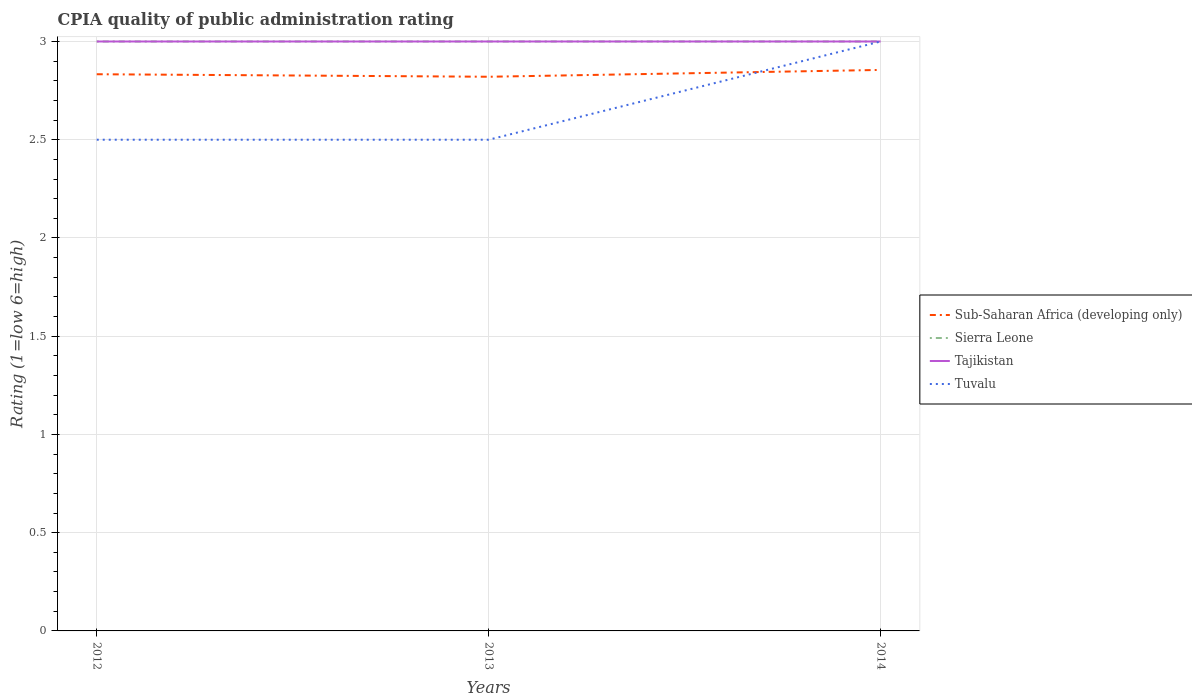Does the line corresponding to Sub-Saharan Africa (developing only) intersect with the line corresponding to Tajikistan?
Your answer should be very brief. No. Is the number of lines equal to the number of legend labels?
Offer a very short reply. Yes. In which year was the CPIA rating in Sierra Leone maximum?
Keep it short and to the point. 2012. What is the total CPIA rating in Sub-Saharan Africa (developing only) in the graph?
Make the answer very short. 0.01. What is the difference between the highest and the second highest CPIA rating in Sub-Saharan Africa (developing only)?
Provide a succinct answer. 0.03. How many lines are there?
Provide a succinct answer. 4. How many years are there in the graph?
Provide a short and direct response. 3. Does the graph contain any zero values?
Offer a very short reply. No. Does the graph contain grids?
Your response must be concise. Yes. Where does the legend appear in the graph?
Your answer should be very brief. Center right. What is the title of the graph?
Keep it short and to the point. CPIA quality of public administration rating. What is the Rating (1=low 6=high) of Sub-Saharan Africa (developing only) in 2012?
Your response must be concise. 2.83. What is the Rating (1=low 6=high) in Tajikistan in 2012?
Provide a short and direct response. 3. What is the Rating (1=low 6=high) of Sub-Saharan Africa (developing only) in 2013?
Offer a terse response. 2.82. What is the Rating (1=low 6=high) of Sierra Leone in 2013?
Your answer should be compact. 3. What is the Rating (1=low 6=high) in Tajikistan in 2013?
Provide a succinct answer. 3. What is the Rating (1=low 6=high) of Tuvalu in 2013?
Offer a terse response. 2.5. What is the Rating (1=low 6=high) in Sub-Saharan Africa (developing only) in 2014?
Provide a succinct answer. 2.86. What is the Rating (1=low 6=high) in Sierra Leone in 2014?
Your answer should be very brief. 3. What is the Rating (1=low 6=high) of Tajikistan in 2014?
Your response must be concise. 3. Across all years, what is the maximum Rating (1=low 6=high) of Sub-Saharan Africa (developing only)?
Give a very brief answer. 2.86. Across all years, what is the maximum Rating (1=low 6=high) of Sierra Leone?
Make the answer very short. 3. Across all years, what is the maximum Rating (1=low 6=high) of Tajikistan?
Provide a succinct answer. 3. Across all years, what is the minimum Rating (1=low 6=high) in Sub-Saharan Africa (developing only)?
Make the answer very short. 2.82. Across all years, what is the minimum Rating (1=low 6=high) of Tuvalu?
Offer a terse response. 2.5. What is the total Rating (1=low 6=high) of Sub-Saharan Africa (developing only) in the graph?
Provide a succinct answer. 8.51. What is the total Rating (1=low 6=high) of Tajikistan in the graph?
Your answer should be compact. 9. What is the difference between the Rating (1=low 6=high) in Sub-Saharan Africa (developing only) in 2012 and that in 2013?
Ensure brevity in your answer.  0.01. What is the difference between the Rating (1=low 6=high) of Tuvalu in 2012 and that in 2013?
Keep it short and to the point. 0. What is the difference between the Rating (1=low 6=high) of Sub-Saharan Africa (developing only) in 2012 and that in 2014?
Offer a terse response. -0.02. What is the difference between the Rating (1=low 6=high) in Sierra Leone in 2012 and that in 2014?
Your answer should be very brief. 0. What is the difference between the Rating (1=low 6=high) of Tajikistan in 2012 and that in 2014?
Your answer should be compact. 0. What is the difference between the Rating (1=low 6=high) in Tuvalu in 2012 and that in 2014?
Give a very brief answer. -0.5. What is the difference between the Rating (1=low 6=high) in Sub-Saharan Africa (developing only) in 2013 and that in 2014?
Keep it short and to the point. -0.03. What is the difference between the Rating (1=low 6=high) of Sierra Leone in 2013 and that in 2014?
Ensure brevity in your answer.  0. What is the difference between the Rating (1=low 6=high) of Sub-Saharan Africa (developing only) in 2012 and the Rating (1=low 6=high) of Sierra Leone in 2013?
Your answer should be very brief. -0.17. What is the difference between the Rating (1=low 6=high) of Sierra Leone in 2012 and the Rating (1=low 6=high) of Tajikistan in 2013?
Provide a short and direct response. 0. What is the difference between the Rating (1=low 6=high) in Sierra Leone in 2012 and the Rating (1=low 6=high) in Tuvalu in 2013?
Your answer should be very brief. 0.5. What is the difference between the Rating (1=low 6=high) in Sub-Saharan Africa (developing only) in 2012 and the Rating (1=low 6=high) in Sierra Leone in 2014?
Keep it short and to the point. -0.17. What is the difference between the Rating (1=low 6=high) in Sub-Saharan Africa (developing only) in 2012 and the Rating (1=low 6=high) in Tajikistan in 2014?
Your answer should be very brief. -0.17. What is the difference between the Rating (1=low 6=high) in Sub-Saharan Africa (developing only) in 2012 and the Rating (1=low 6=high) in Tuvalu in 2014?
Offer a terse response. -0.17. What is the difference between the Rating (1=low 6=high) in Tajikistan in 2012 and the Rating (1=low 6=high) in Tuvalu in 2014?
Your answer should be compact. 0. What is the difference between the Rating (1=low 6=high) of Sub-Saharan Africa (developing only) in 2013 and the Rating (1=low 6=high) of Sierra Leone in 2014?
Keep it short and to the point. -0.18. What is the difference between the Rating (1=low 6=high) of Sub-Saharan Africa (developing only) in 2013 and the Rating (1=low 6=high) of Tajikistan in 2014?
Offer a very short reply. -0.18. What is the difference between the Rating (1=low 6=high) in Sub-Saharan Africa (developing only) in 2013 and the Rating (1=low 6=high) in Tuvalu in 2014?
Keep it short and to the point. -0.18. What is the difference between the Rating (1=low 6=high) of Tajikistan in 2013 and the Rating (1=low 6=high) of Tuvalu in 2014?
Your answer should be very brief. 0. What is the average Rating (1=low 6=high) in Sub-Saharan Africa (developing only) per year?
Your response must be concise. 2.84. What is the average Rating (1=low 6=high) of Sierra Leone per year?
Your response must be concise. 3. What is the average Rating (1=low 6=high) in Tajikistan per year?
Provide a succinct answer. 3. What is the average Rating (1=low 6=high) of Tuvalu per year?
Provide a short and direct response. 2.67. In the year 2012, what is the difference between the Rating (1=low 6=high) of Sub-Saharan Africa (developing only) and Rating (1=low 6=high) of Tajikistan?
Keep it short and to the point. -0.17. In the year 2012, what is the difference between the Rating (1=low 6=high) of Sub-Saharan Africa (developing only) and Rating (1=low 6=high) of Tuvalu?
Provide a succinct answer. 0.33. In the year 2012, what is the difference between the Rating (1=low 6=high) of Tajikistan and Rating (1=low 6=high) of Tuvalu?
Give a very brief answer. 0.5. In the year 2013, what is the difference between the Rating (1=low 6=high) in Sub-Saharan Africa (developing only) and Rating (1=low 6=high) in Sierra Leone?
Provide a succinct answer. -0.18. In the year 2013, what is the difference between the Rating (1=low 6=high) of Sub-Saharan Africa (developing only) and Rating (1=low 6=high) of Tajikistan?
Ensure brevity in your answer.  -0.18. In the year 2013, what is the difference between the Rating (1=low 6=high) of Sub-Saharan Africa (developing only) and Rating (1=low 6=high) of Tuvalu?
Your response must be concise. 0.32. In the year 2013, what is the difference between the Rating (1=low 6=high) in Sierra Leone and Rating (1=low 6=high) in Tajikistan?
Provide a succinct answer. 0. In the year 2013, what is the difference between the Rating (1=low 6=high) in Sierra Leone and Rating (1=low 6=high) in Tuvalu?
Ensure brevity in your answer.  0.5. In the year 2013, what is the difference between the Rating (1=low 6=high) in Tajikistan and Rating (1=low 6=high) in Tuvalu?
Your answer should be compact. 0.5. In the year 2014, what is the difference between the Rating (1=low 6=high) in Sub-Saharan Africa (developing only) and Rating (1=low 6=high) in Sierra Leone?
Provide a succinct answer. -0.14. In the year 2014, what is the difference between the Rating (1=low 6=high) in Sub-Saharan Africa (developing only) and Rating (1=low 6=high) in Tajikistan?
Ensure brevity in your answer.  -0.14. In the year 2014, what is the difference between the Rating (1=low 6=high) in Sub-Saharan Africa (developing only) and Rating (1=low 6=high) in Tuvalu?
Keep it short and to the point. -0.14. In the year 2014, what is the difference between the Rating (1=low 6=high) of Sierra Leone and Rating (1=low 6=high) of Tajikistan?
Provide a short and direct response. 0. What is the ratio of the Rating (1=low 6=high) in Sierra Leone in 2012 to that in 2013?
Your response must be concise. 1. What is the ratio of the Rating (1=low 6=high) of Sierra Leone in 2012 to that in 2014?
Ensure brevity in your answer.  1. What is the ratio of the Rating (1=low 6=high) of Tajikistan in 2012 to that in 2014?
Provide a succinct answer. 1. What is the difference between the highest and the second highest Rating (1=low 6=high) of Sub-Saharan Africa (developing only)?
Offer a terse response. 0.02. What is the difference between the highest and the second highest Rating (1=low 6=high) in Tajikistan?
Offer a very short reply. 0. What is the difference between the highest and the second highest Rating (1=low 6=high) of Tuvalu?
Offer a very short reply. 0.5. What is the difference between the highest and the lowest Rating (1=low 6=high) of Sub-Saharan Africa (developing only)?
Keep it short and to the point. 0.03. What is the difference between the highest and the lowest Rating (1=low 6=high) of Sierra Leone?
Offer a terse response. 0. What is the difference between the highest and the lowest Rating (1=low 6=high) of Tuvalu?
Your response must be concise. 0.5. 